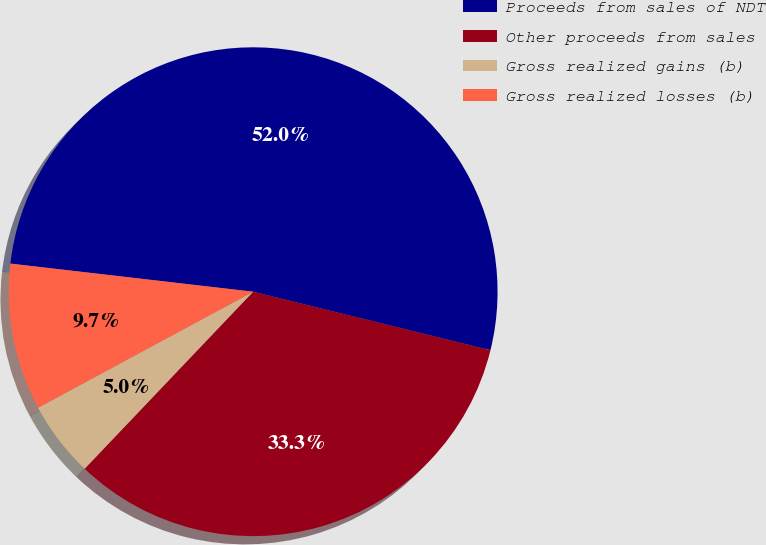<chart> <loc_0><loc_0><loc_500><loc_500><pie_chart><fcel>Proceeds from sales of NDT<fcel>Other proceeds from sales<fcel>Gross realized gains (b)<fcel>Gross realized losses (b)<nl><fcel>52.01%<fcel>33.26%<fcel>5.02%<fcel>9.71%<nl></chart> 